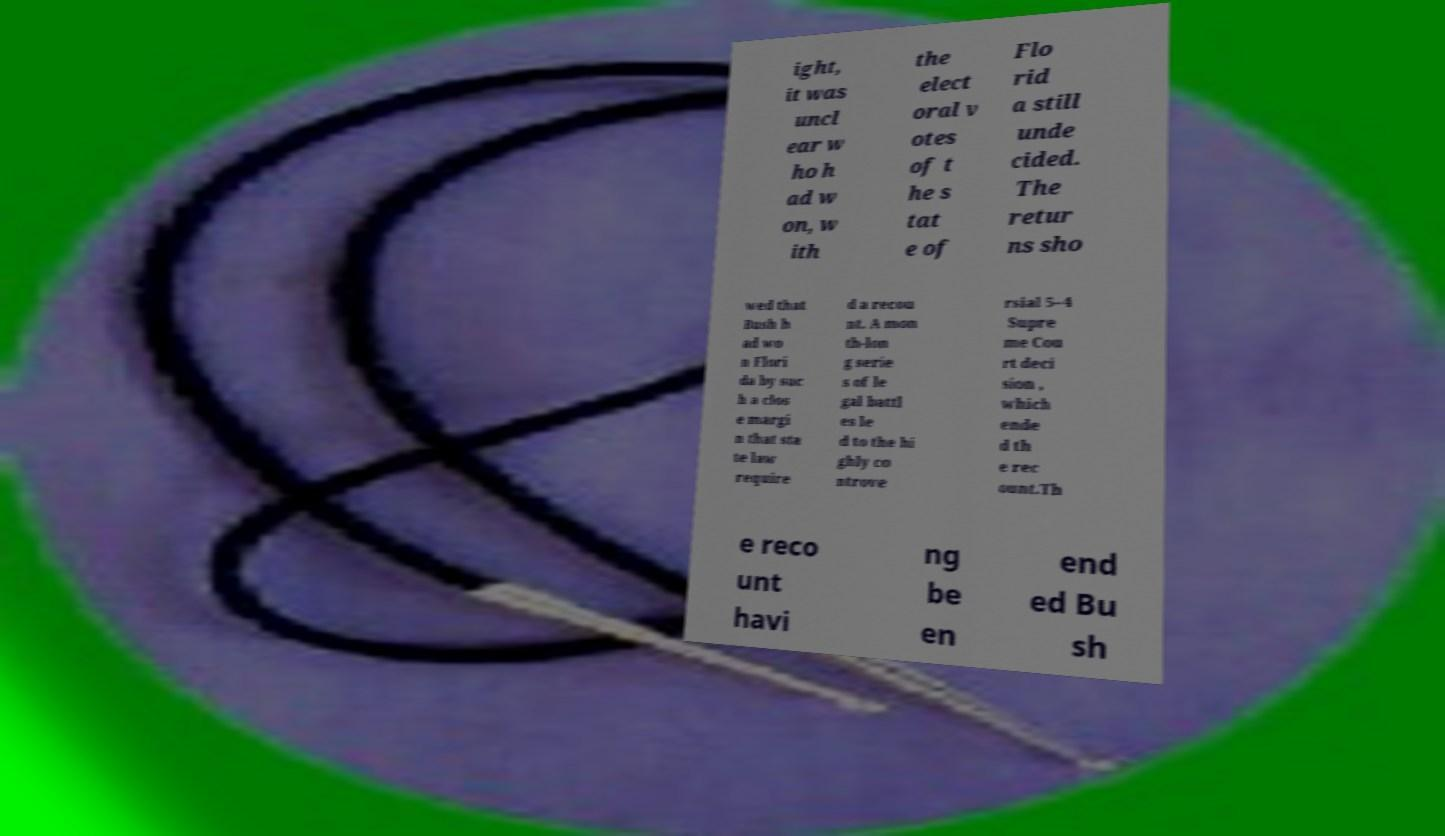There's text embedded in this image that I need extracted. Can you transcribe it verbatim? ight, it was uncl ear w ho h ad w on, w ith the elect oral v otes of t he s tat e of Flo rid a still unde cided. The retur ns sho wed that Bush h ad wo n Flori da by suc h a clos e margi n that sta te law require d a recou nt. A mon th-lon g serie s of le gal battl es le d to the hi ghly co ntrove rsial 5–4 Supre me Cou rt deci sion , which ende d th e rec ount.Th e reco unt havi ng be en end ed Bu sh 